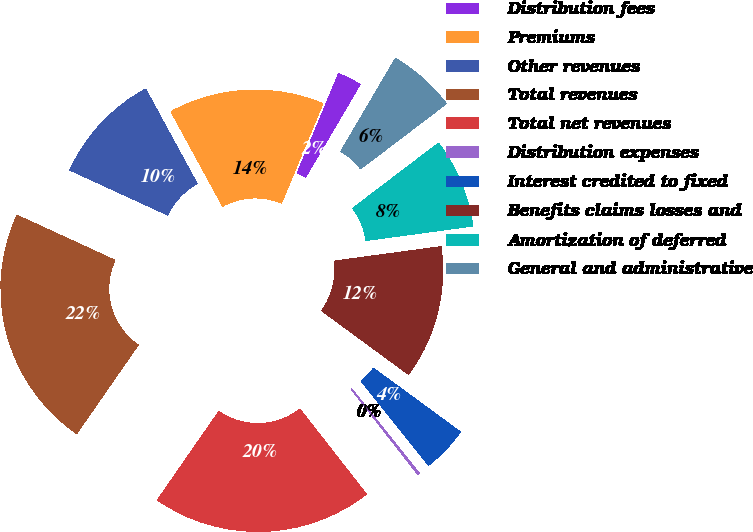Convert chart. <chart><loc_0><loc_0><loc_500><loc_500><pie_chart><fcel>Distribution fees<fcel>Premiums<fcel>Other revenues<fcel>Total revenues<fcel>Total net revenues<fcel>Distribution expenses<fcel>Interest credited to fixed<fcel>Benefits claims losses and<fcel>Amortization of deferred<fcel>General and administrative<nl><fcel>2.19%<fcel>14.21%<fcel>10.2%<fcel>22.21%<fcel>20.21%<fcel>0.19%<fcel>4.19%<fcel>12.21%<fcel>8.2%<fcel>6.2%<nl></chart> 